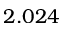<formula> <loc_0><loc_0><loc_500><loc_500>2 . 0 2 4</formula> 